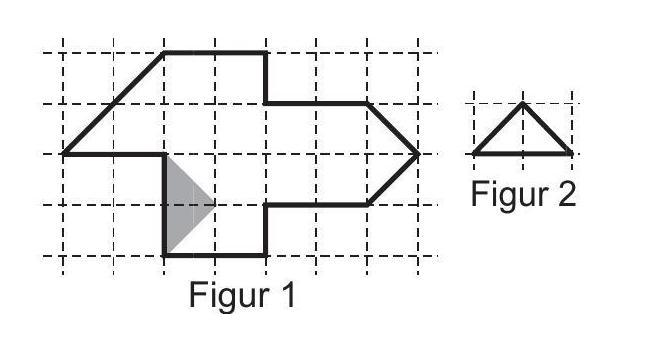Luca wants to cut the shape in figure 1 into equally sized small triangles (like those in figure 2). One of these triangles is already drawn on figure 1. How many of these triangles will he get?
 Answer is 15. 